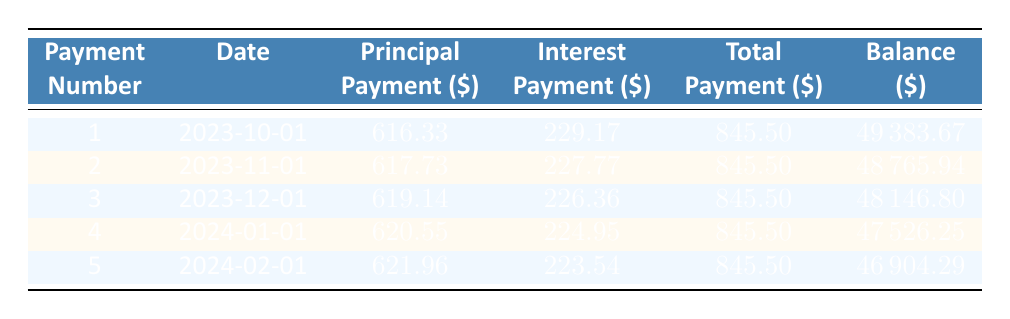What is the monthly payment amount for the equipment financing? The monthly payment amount is explicitly provided in the data, which states it is 958.33.
Answer: 958.33 What is the total interest payment for the first month? The table lists the interest payment for the first payment, which is 229.17.
Answer: 229.17 What is the remaining balance after the second payment? Looking at the table, the remaining balance after the second payment (payment number 2) is 48765.94.
Answer: 48765.94 How much did the principal payment increase from the first month to the second month? The principal payment for the first month is 616.33 and for the second month is 617.73. So, the increase is 617.73 - 616.33 = 1.40.
Answer: 1.40 Is the interest payment for the fourth month greater than that of the third month? The interest payment for the fourth month is 224.95 and for the third month is 226.36. Since 224.95 is less than 226.36, the statement is false.
Answer: No What is the total principal payment made over the first five months? The principal payments for the first five months are 616.33, 617.73, 619.14, 620.55, and 621.96. Summing these amounts gives 616.33 + 617.73 + 619.14 + 620.55 + 621.96 = 3195.71.
Answer: 3195.71 What is the average total payment over the first five months? Each monthly total payment is 845.50, and since there are five payments, the average total payment is 845.50 (the total payment remains constant).
Answer: 845.50 What is the remaining balance after the fifth payment? The table indicates that the remaining balance after the fifth payment is 46904.29.
Answer: 46904.29 How much total payment will be made over the entire loan term? The loan term is for five years, with monthly payments of 845.50. There are a total of 5 years x 12 months = 60 payments, so the total payment will be 60 x 845.50 = 50730.00.
Answer: 50730.00 